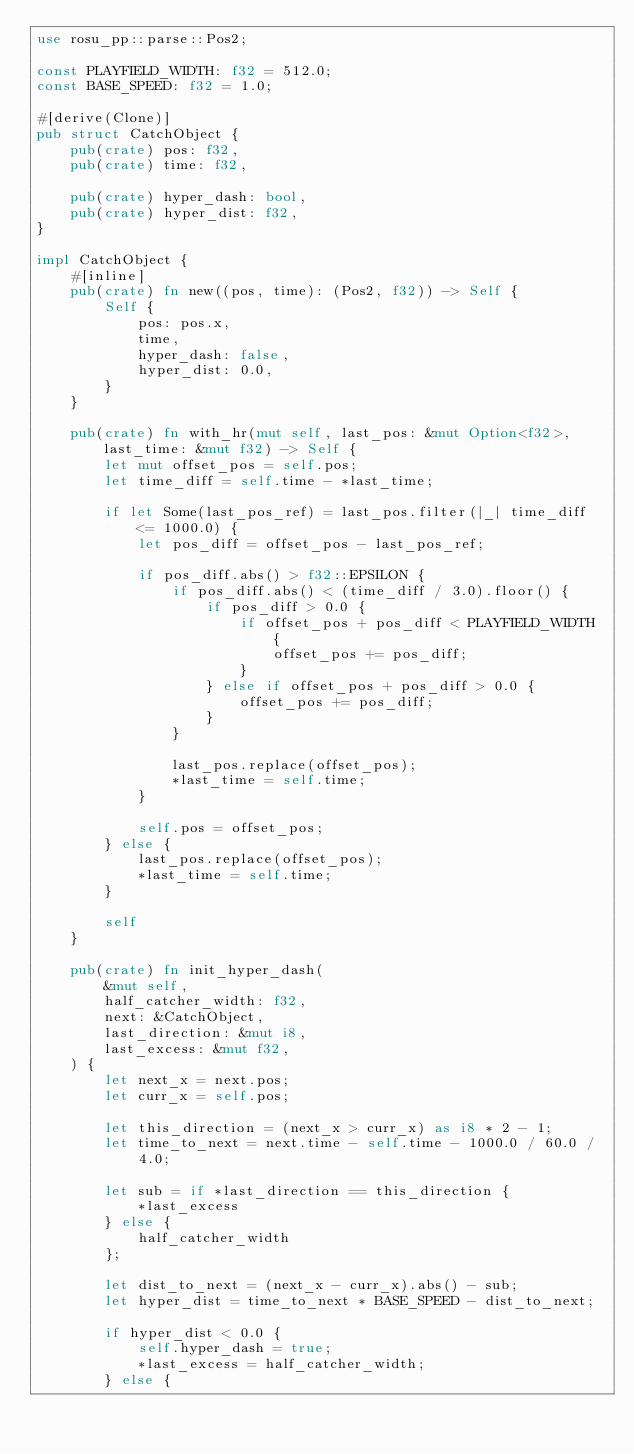Convert code to text. <code><loc_0><loc_0><loc_500><loc_500><_Rust_>use rosu_pp::parse::Pos2;

const PLAYFIELD_WIDTH: f32 = 512.0;
const BASE_SPEED: f32 = 1.0;

#[derive(Clone)]
pub struct CatchObject {
    pub(crate) pos: f32,
    pub(crate) time: f32,

    pub(crate) hyper_dash: bool,
    pub(crate) hyper_dist: f32,
}

impl CatchObject {
    #[inline]
    pub(crate) fn new((pos, time): (Pos2, f32)) -> Self {
        Self {
            pos: pos.x,
            time,
            hyper_dash: false,
            hyper_dist: 0.0,
        }
    }

    pub(crate) fn with_hr(mut self, last_pos: &mut Option<f32>, last_time: &mut f32) -> Self {
        let mut offset_pos = self.pos;
        let time_diff = self.time - *last_time;

        if let Some(last_pos_ref) = last_pos.filter(|_| time_diff <= 1000.0) {
            let pos_diff = offset_pos - last_pos_ref;

            if pos_diff.abs() > f32::EPSILON {
                if pos_diff.abs() < (time_diff / 3.0).floor() {
                    if pos_diff > 0.0 {
                        if offset_pos + pos_diff < PLAYFIELD_WIDTH {
                            offset_pos += pos_diff;
                        }
                    } else if offset_pos + pos_diff > 0.0 {
                        offset_pos += pos_diff;
                    }
                }

                last_pos.replace(offset_pos);
                *last_time = self.time;
            }

            self.pos = offset_pos;
        } else {
            last_pos.replace(offset_pos);
            *last_time = self.time;
        }

        self
    }

    pub(crate) fn init_hyper_dash(
        &mut self,
        half_catcher_width: f32,
        next: &CatchObject,
        last_direction: &mut i8,
        last_excess: &mut f32,
    ) {
        let next_x = next.pos;
        let curr_x = self.pos;

        let this_direction = (next_x > curr_x) as i8 * 2 - 1;
        let time_to_next = next.time - self.time - 1000.0 / 60.0 / 4.0;

        let sub = if *last_direction == this_direction {
            *last_excess
        } else {
            half_catcher_width
        };

        let dist_to_next = (next_x - curr_x).abs() - sub;
        let hyper_dist = time_to_next * BASE_SPEED - dist_to_next;

        if hyper_dist < 0.0 {
            self.hyper_dash = true;
            *last_excess = half_catcher_width;
        } else {</code> 